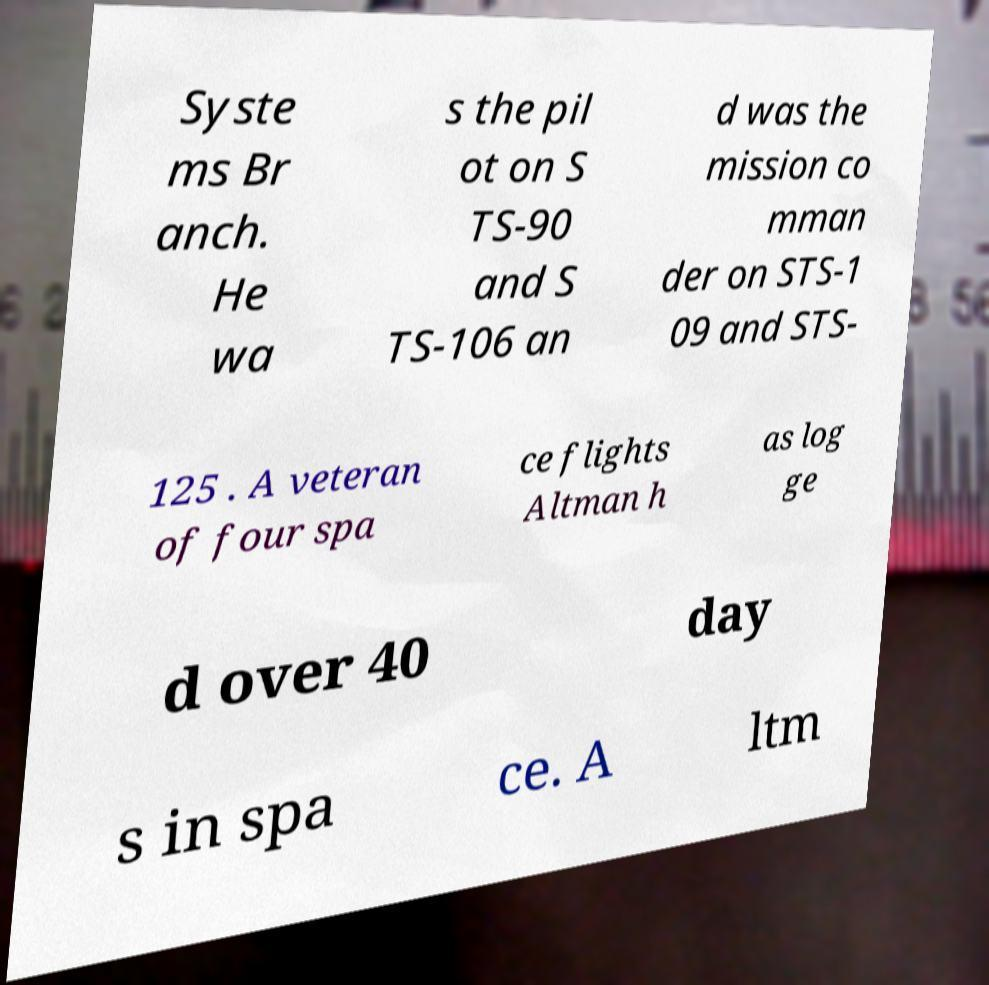There's text embedded in this image that I need extracted. Can you transcribe it verbatim? Syste ms Br anch. He wa s the pil ot on S TS-90 and S TS-106 an d was the mission co mman der on STS-1 09 and STS- 125 . A veteran of four spa ce flights Altman h as log ge d over 40 day s in spa ce. A ltm 